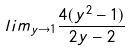Convert formula to latex. <formula><loc_0><loc_0><loc_500><loc_500>l i m _ { y \rightarrow 1 } \frac { 4 ( y ^ { 2 } - 1 ) } { 2 y - 2 }</formula> 